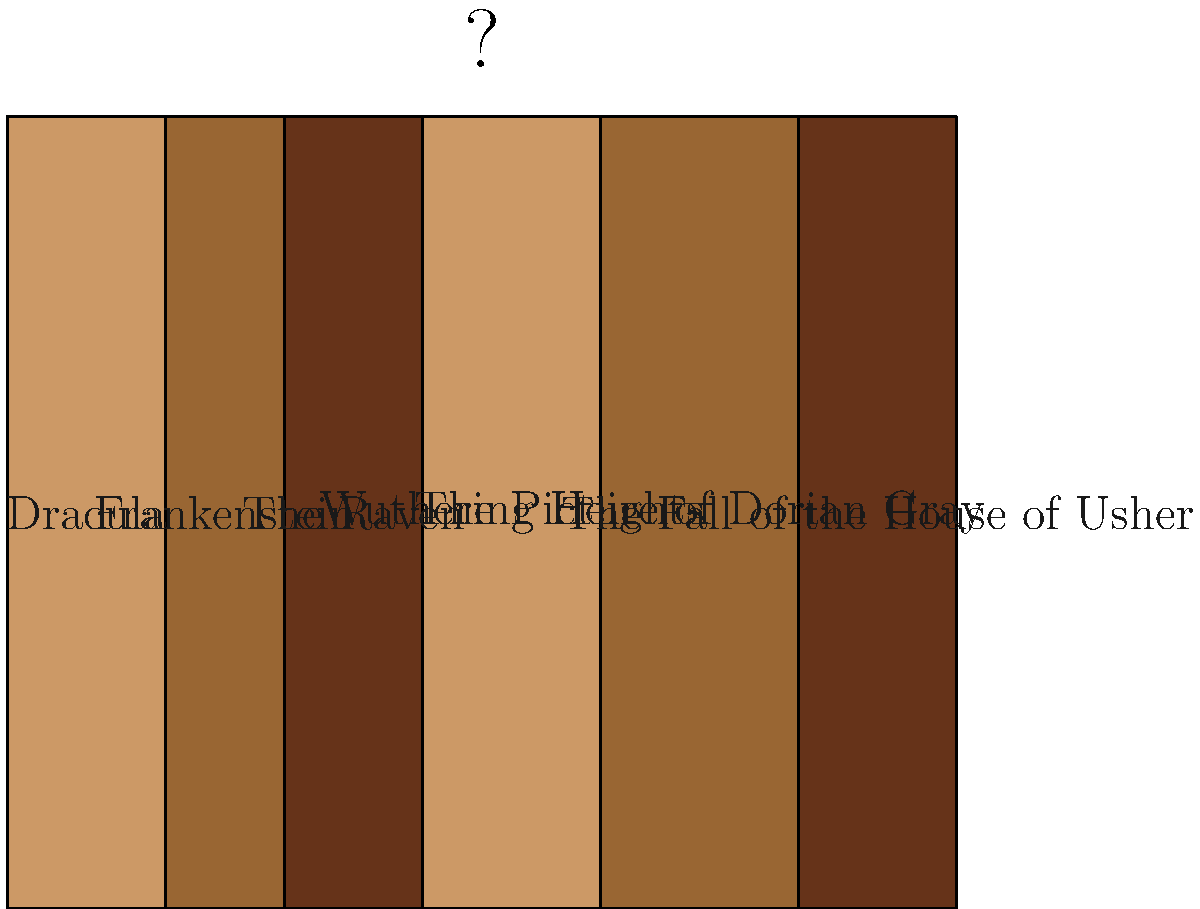Arrange the book spines in the correct order to reveal a hidden symbol associated with gothic literature. What symbol emerges when the books are properly arranged? To solve this visual puzzle and reveal the hidden symbol associated with gothic literature, follow these steps:

1. Examine the book titles: "Dracula", "Frankenstein", "The Raven", "Wuthering Heights", "The Picture of Dorian Gray", and "The Fall of the House of Usher".

2. Notice that each book spine has a different width and color.

3. Rearrange the books based on the first letter of each title:
   - D: Dracula
   - F: Frankenstein
   - H: The Fall of the House of Usher
   - P: The Picture of Dorian Gray
   - R: The Raven
   - W: Wuthering Heights

4. When arranged in this order, the varying widths of the book spines create a silhouette.

5. The silhouette formed by the properly arranged book spines resembles a bat - a common symbol in gothic literature, often associated with vampires and the supernatural.

6. The bat symbol is particularly fitting given the presence of "Dracula" among the book titles, as bats are closely linked to vampire lore.
Answer: Bat 